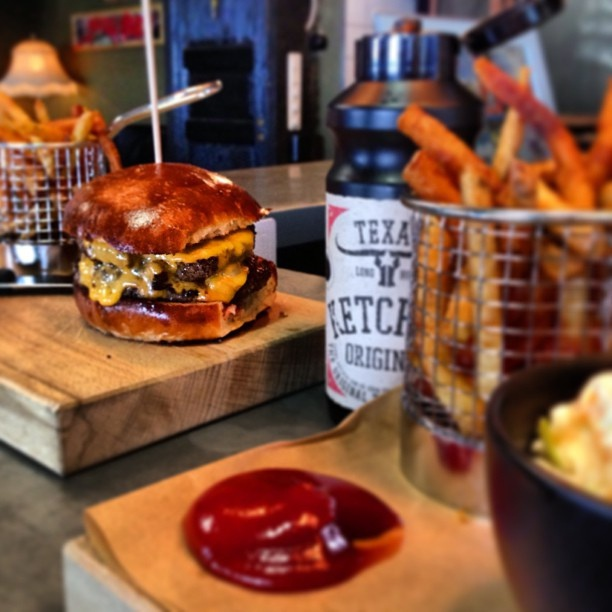Describe the objects in this image and their specific colors. I can see bottle in black, lavender, darkgray, and gray tones, sandwich in black, maroon, and brown tones, bowl in black, maroon, orange, and khaki tones, and spoon in black, lightgray, gray, and darkgray tones in this image. 